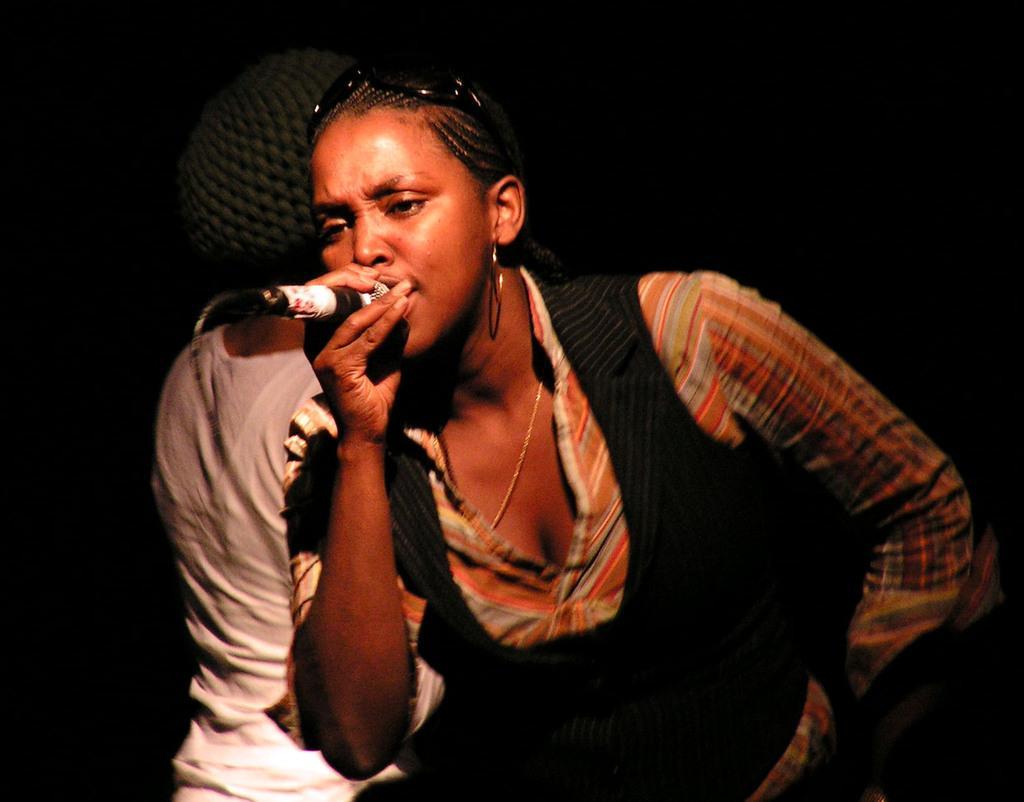Describe this image in one or two sentences. There are two women in the image. The woman in the front is holding a microphone and singing. She is wearing a chain and a colorful shirt with a black vest on it. She is wearing sunglasses on her head. The woman behind her is turned around.  